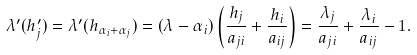<formula> <loc_0><loc_0><loc_500><loc_500>\lambda ^ { \prime } ( h ^ { \prime } _ { j } ) = \lambda ^ { \prime } ( h _ { \alpha _ { i } + \alpha _ { j } } ) = ( \lambda - \alpha _ { i } ) \left ( \frac { h _ { j } } { a _ { j i } } + \frac { h _ { i } } { a _ { i j } } \right ) = \frac { \lambda _ { j } } { a _ { j i } } + \frac { \lambda _ { i } } { a _ { i j } } - 1 .</formula> 